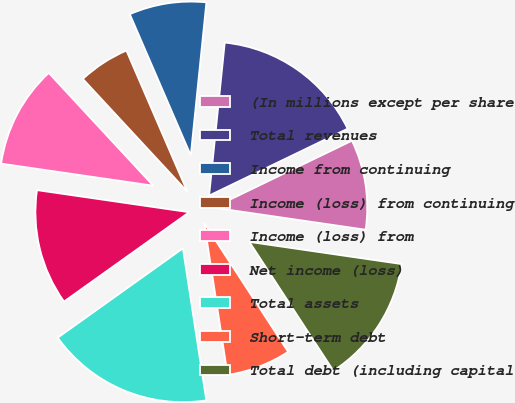<chart> <loc_0><loc_0><loc_500><loc_500><pie_chart><fcel>(In millions except per share<fcel>Total revenues<fcel>Income from continuing<fcel>Income (loss) from continuing<fcel>Income (loss) from<fcel>Net income (loss)<fcel>Total assets<fcel>Short-term debt<fcel>Total debt (including capital<nl><fcel>9.46%<fcel>16.22%<fcel>8.11%<fcel>5.41%<fcel>10.81%<fcel>12.16%<fcel>17.57%<fcel>6.76%<fcel>13.51%<nl></chart> 